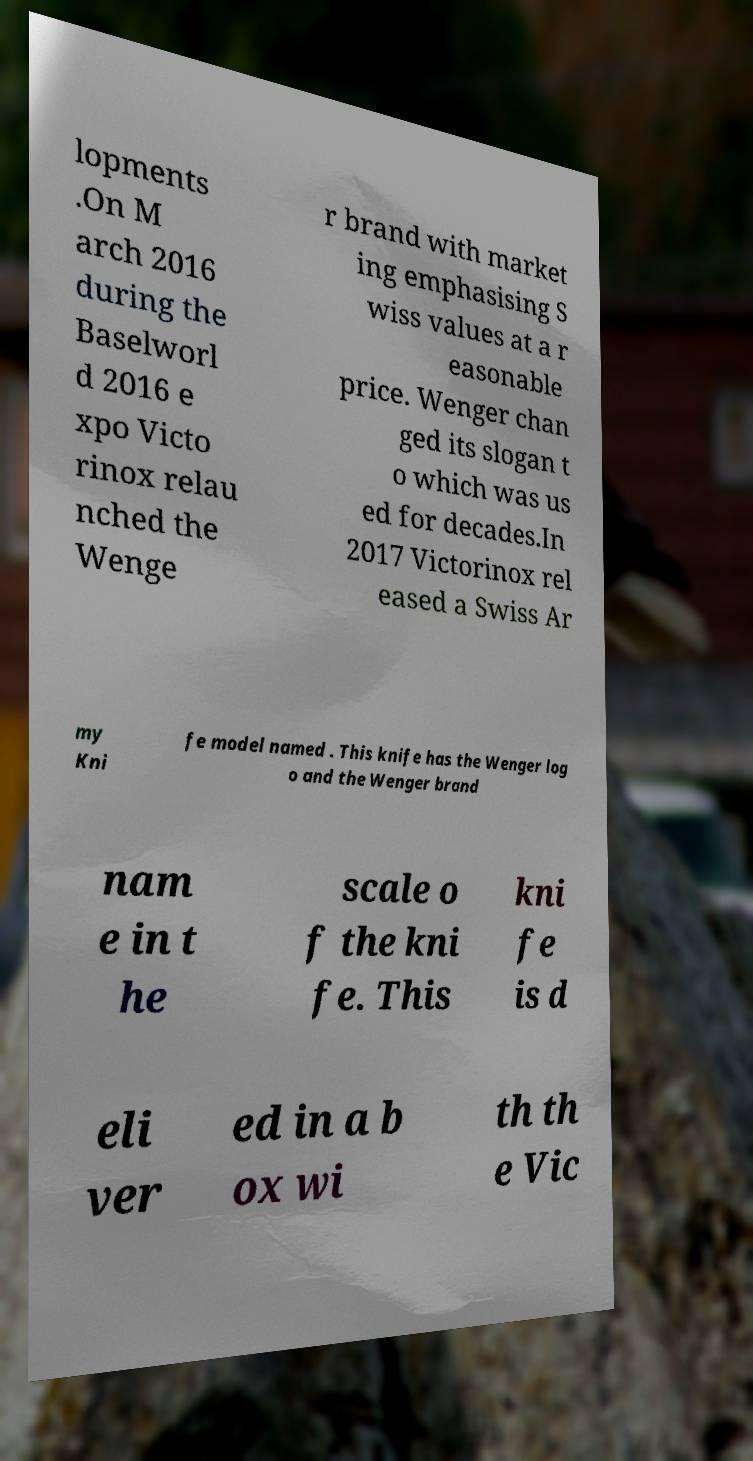For documentation purposes, I need the text within this image transcribed. Could you provide that? lopments .On M arch 2016 during the Baselworl d 2016 e xpo Victo rinox relau nched the Wenge r brand with market ing emphasising S wiss values at a r easonable price. Wenger chan ged its slogan t o which was us ed for decades.In 2017 Victorinox rel eased a Swiss Ar my Kni fe model named . This knife has the Wenger log o and the Wenger brand nam e in t he scale o f the kni fe. This kni fe is d eli ver ed in a b ox wi th th e Vic 